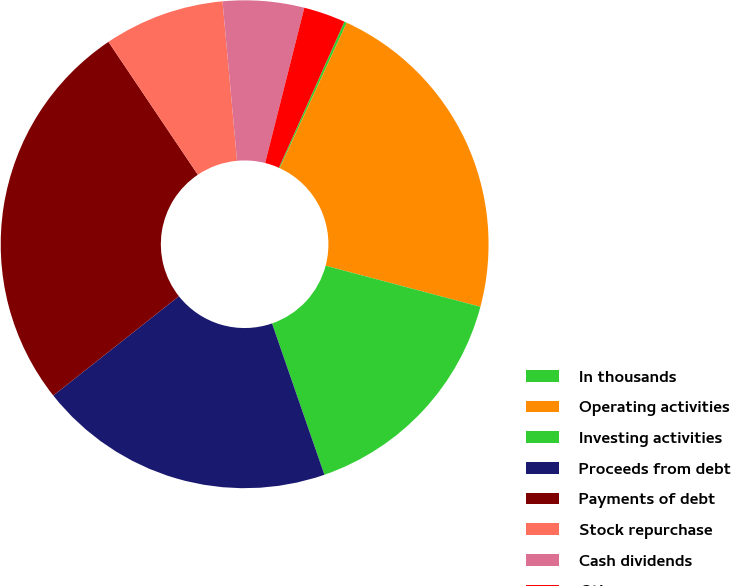<chart> <loc_0><loc_0><loc_500><loc_500><pie_chart><fcel>In thousands<fcel>Operating activities<fcel>Investing activities<fcel>Proceeds from debt<fcel>Payments of debt<fcel>Stock repurchase<fcel>Cash dividends<fcel>Other<nl><fcel>0.17%<fcel>22.25%<fcel>15.57%<fcel>19.65%<fcel>26.22%<fcel>7.98%<fcel>5.38%<fcel>2.77%<nl></chart> 